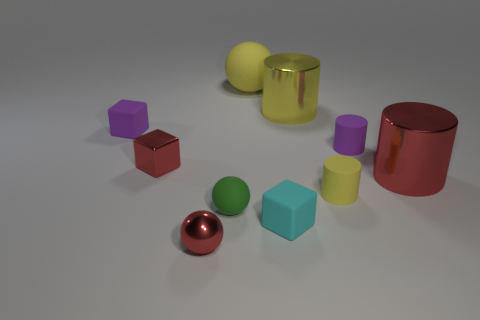Is the number of cyan rubber objects greater than the number of big brown matte cylinders?
Keep it short and to the point. Yes. The large metal cylinder in front of the tiny purple rubber thing left of the rubber cube in front of the red cylinder is what color?
Your response must be concise. Red. Is the shape of the purple thing to the right of the small purple rubber block the same as  the yellow metal thing?
Offer a terse response. Yes. There is a rubber sphere that is the same size as the red metallic block; what is its color?
Your answer should be very brief. Green. What number of matte blocks are there?
Make the answer very short. 2. Do the cube behind the small red metallic block and the yellow sphere have the same material?
Your response must be concise. Yes. What material is the red object that is to the left of the yellow metal thing and behind the tiny yellow cylinder?
Keep it short and to the point. Metal. There is a cylinder that is the same color as the small shiny cube; what is its size?
Give a very brief answer. Large. What material is the big object left of the cyan matte cube in front of the small yellow object made of?
Give a very brief answer. Rubber. There is a yellow matte thing behind the matte cube that is behind the small green matte ball that is in front of the red metallic cube; how big is it?
Provide a succinct answer. Large. 